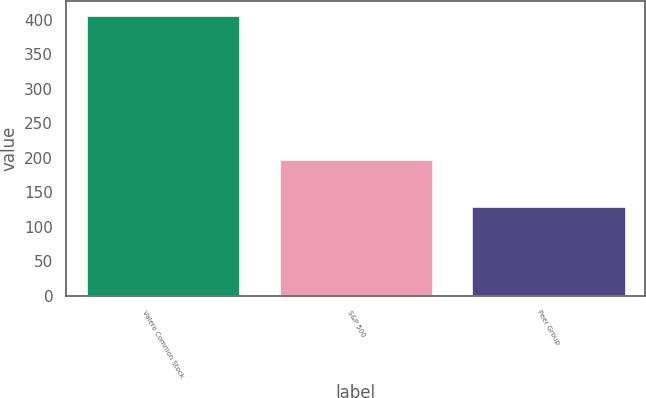Convert chart to OTSL. <chart><loc_0><loc_0><loc_500><loc_500><bar_chart><fcel>Valero Common Stock<fcel>S&P 500<fcel>Peer Group<nl><fcel>406.63<fcel>198.18<fcel>130.66<nl></chart> 